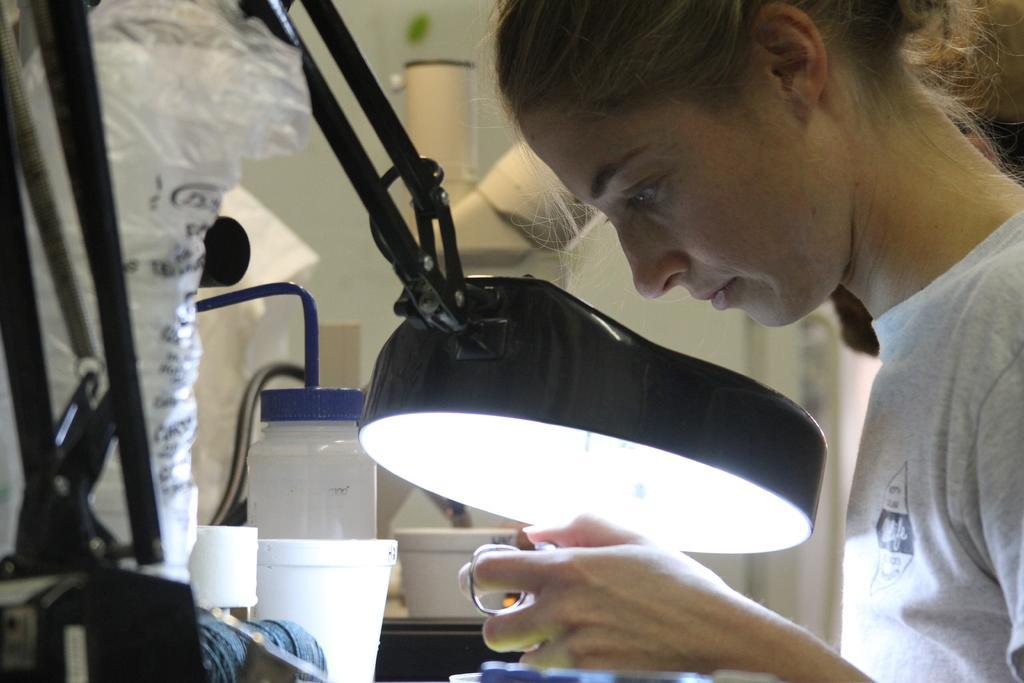Describe this image in one or two sentences. In this image we can see a girl holding an object, in front of her there is a lamp and some other objects. 